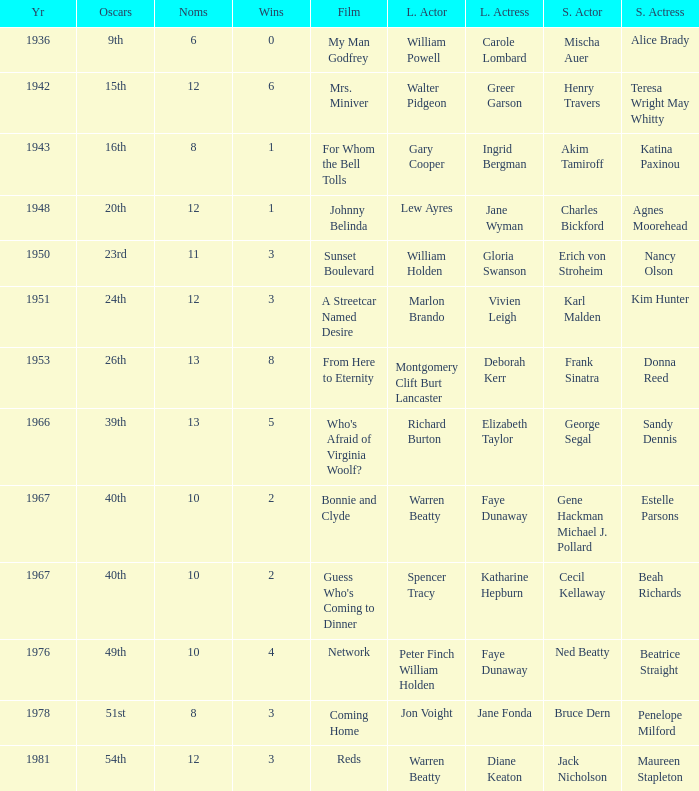Who was the supporting actress in 1943? Katina Paxinou. 